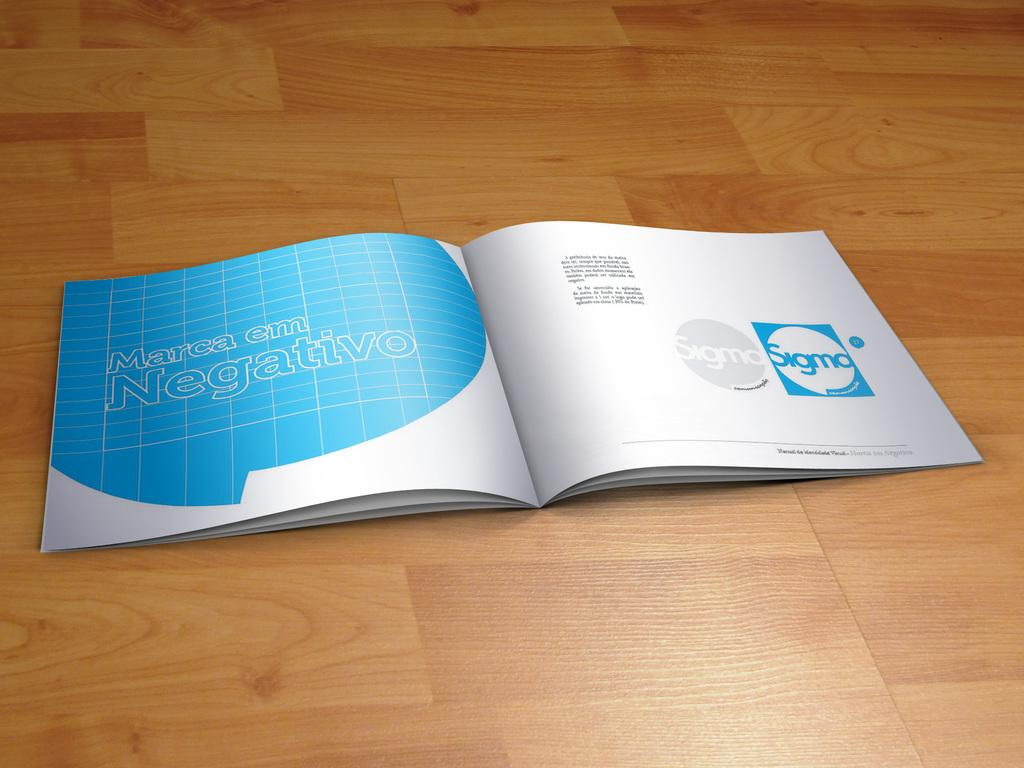<image>
Provide a brief description of the given image. A booklet is open to a page that says Sigma twice on it. 